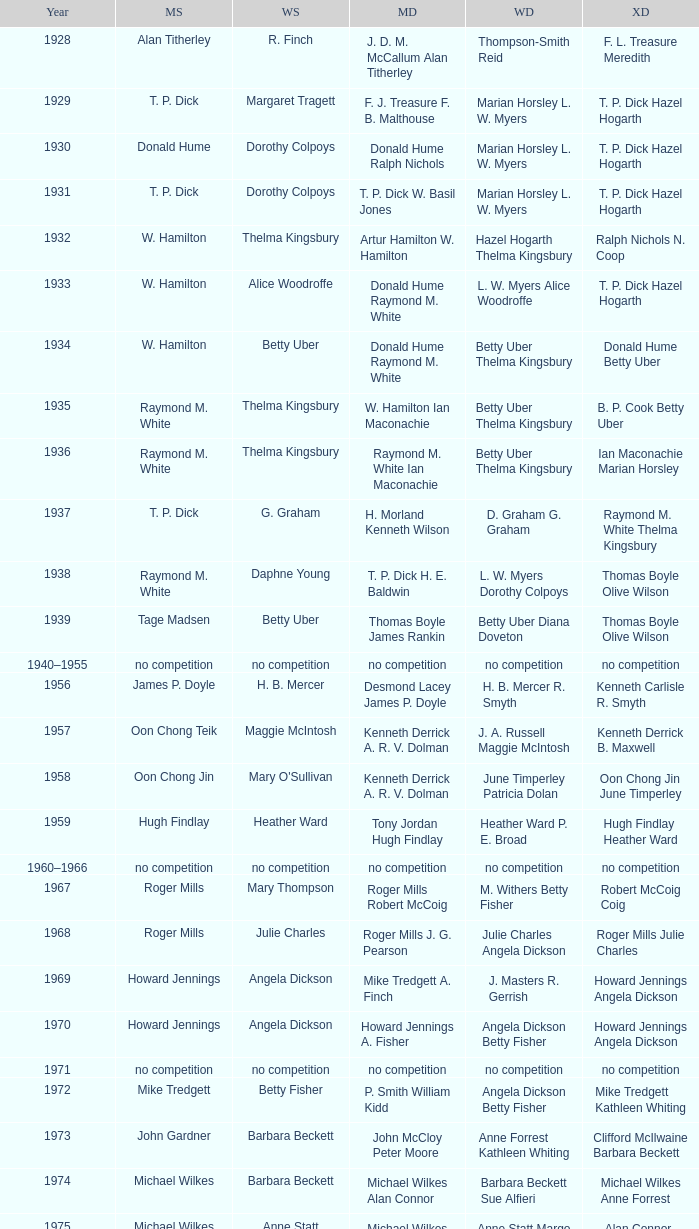Who claimed victory in the women's singles, in the same year that raymond m. white achieved success in the men's singles and w. hamilton ian maconachie conquered the men's doubles? Thelma Kingsbury. 